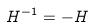<formula> <loc_0><loc_0><loc_500><loc_500>H ^ { - 1 } = - H</formula> 